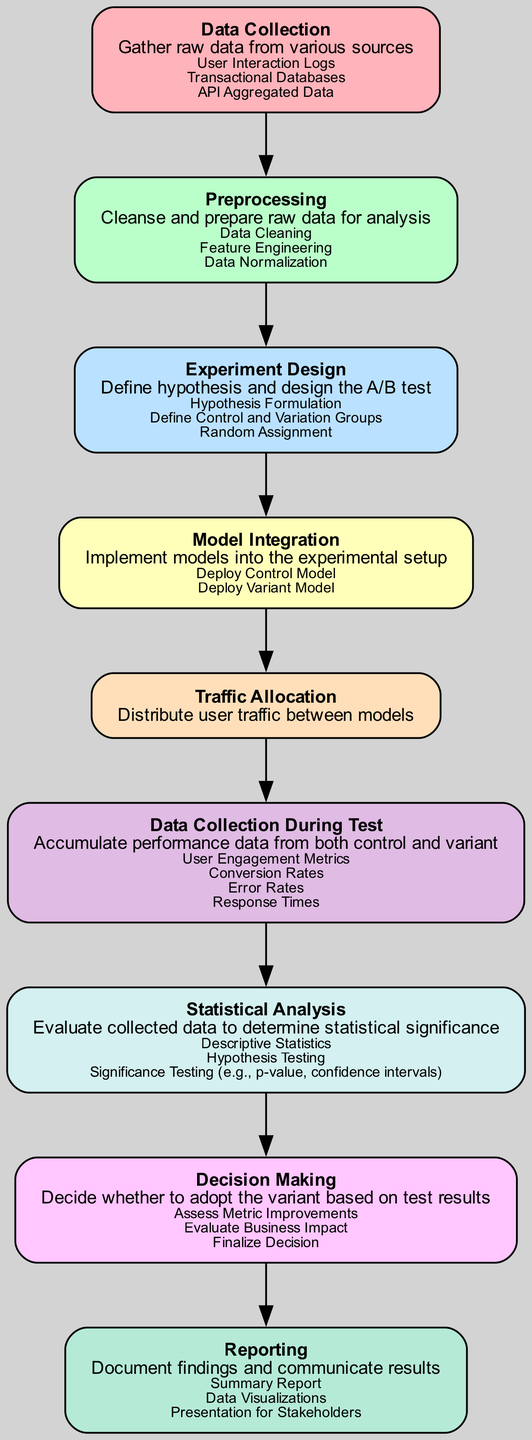What is the first step in the A/B testing workflow? The diagram shows that the first node is "Data Collection," which represents the initial step of gathering data.
Answer: Data Collection How many sub-elements are listed under "Preprocessing"? The "Preprocessing" element contains three sub-elements: "Data Cleaning," "Feature Engineering," and "Data Normalization," as visible in the diagram.
Answer: 3 What do we do after "Traffic Allocation"? The next step after "Traffic Allocation" is "Data Collection During Test," indicating that user performance data is gathered.
Answer: Data Collection During Test Which element follows "Model Integration"? The diagram reveals that "Traffic Allocation" is the element that comes directly after "Model Integration," indicating user traffic distribution.
Answer: Traffic Allocation Name the statistical method mentioned under "Statistical Analysis." The diagram lists "Descriptive Statistics," "Hypothesis Testing," and "Significance Testing," but "Hypothesis Testing" is one of the key methods noted.
Answer: Hypothesis Testing What element focuses on documenting findings? According to the diagram, "Reporting" is the element dedicated to summarizing and communicating the results of the A/B testing workflow.
Answer: Reporting How many total nodes are present in the workflow? Counting the nodes in the diagram reveals that there are a total of nine nodes representing different steps in the workflow.
Answer: 9 What is the purpose of the "Experiment Design" stage? The "Experiment Design" stage is crucial for defining the hypothesis and setting up the A/B test, including establishing control and variation groups.
Answer: Define hypothesis and design the A/B test Which element comes before "Decision Making"? The diagram indicates that "Statistical Analysis" comes prior to "Decision Making," meaning that data evaluation aids in final decision-making.
Answer: Statistical Analysis 